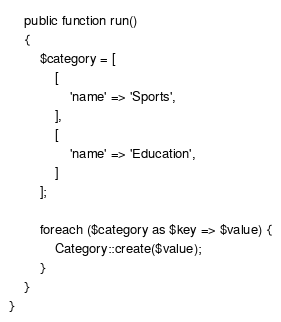Convert code to text. <code><loc_0><loc_0><loc_500><loc_500><_PHP_>    public function run()
    {
        $category = [
            [
                'name' => 'Sports',
            ],
            [
                'name' => 'Education',
            ]
        ];

        foreach ($category as $key => $value) {
            Category::create($value);
        }
    }
}
</code> 